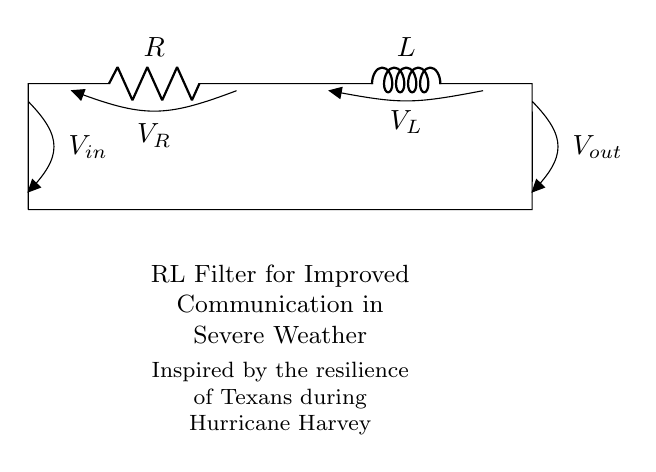What components are present in this filter circuit? The circuit consists of a resistor (R) and an inductor (L), as indicated by their labels in the diagram.
Answer: Resistor and Inductor What is the purpose of this RL filter circuit? The diagram indicates that the purpose of the circuit is to improve communication, especially during severe weather conditions, as mentioned in the accompanying text.
Answer: Improved communication What is the voltage across the resistor in this circuit? The voltage across the resistor is labeled as 'V_R', directly stating its potential difference measurement within the circuit.
Answer: V_R How does the inductor affect the signal in this circuit? The inductor serves to filter the frequency of the signal, allowing lower frequencies to pass while attenuating higher frequencies, which is critical for maintaining communication during severe weather.
Answer: Filters frequencies What is the voltage input value in this RL filter? The input voltage is labeled as 'V_in', which denotes the voltage supplied to the circuit for operation.
Answer: V_in What does the text under the circuit denote? The text indicates the inspiration behind the design of the circuit, highlighting its relevance and resilience relating to the experiences of Texans during Hurricane Harvey.
Answer: Inspired by resilience What effect does the combination of R and L have on the circuit performance? The combination of the resistor and inductor creates a phase shift and attenuates higher frequency noise, leading to a smoother communication signal during disturbances.
Answer: Attenuates noise 